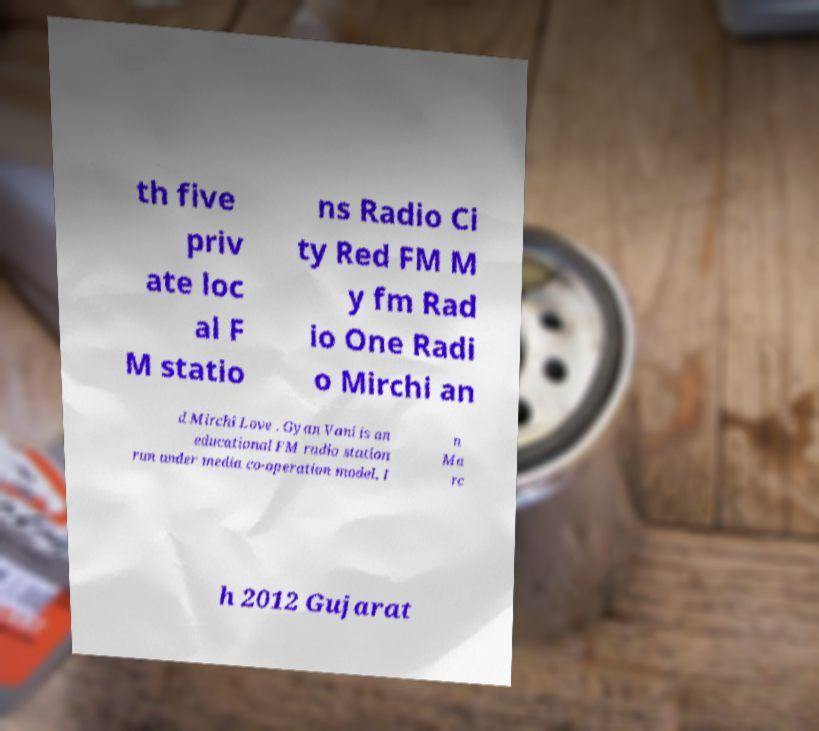What messages or text are displayed in this image? I need them in a readable, typed format. th five priv ate loc al F M statio ns Radio Ci ty Red FM M y fm Rad io One Radi o Mirchi an d Mirchi Love . Gyan Vani is an educational FM radio station run under media co-operation model. I n Ma rc h 2012 Gujarat 